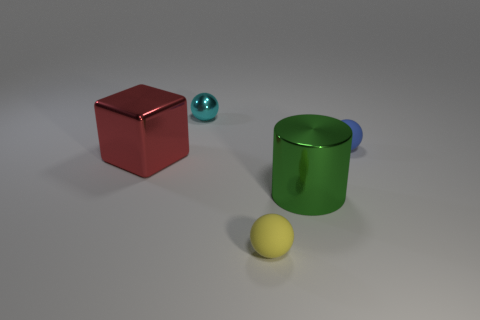Add 2 cyan metal balls. How many objects exist? 7 Subtract all cylinders. How many objects are left? 4 Add 2 metallic cubes. How many metallic cubes are left? 3 Add 2 green things. How many green things exist? 3 Subtract 0 green spheres. How many objects are left? 5 Subtract all green metal cylinders. Subtract all blue matte things. How many objects are left? 3 